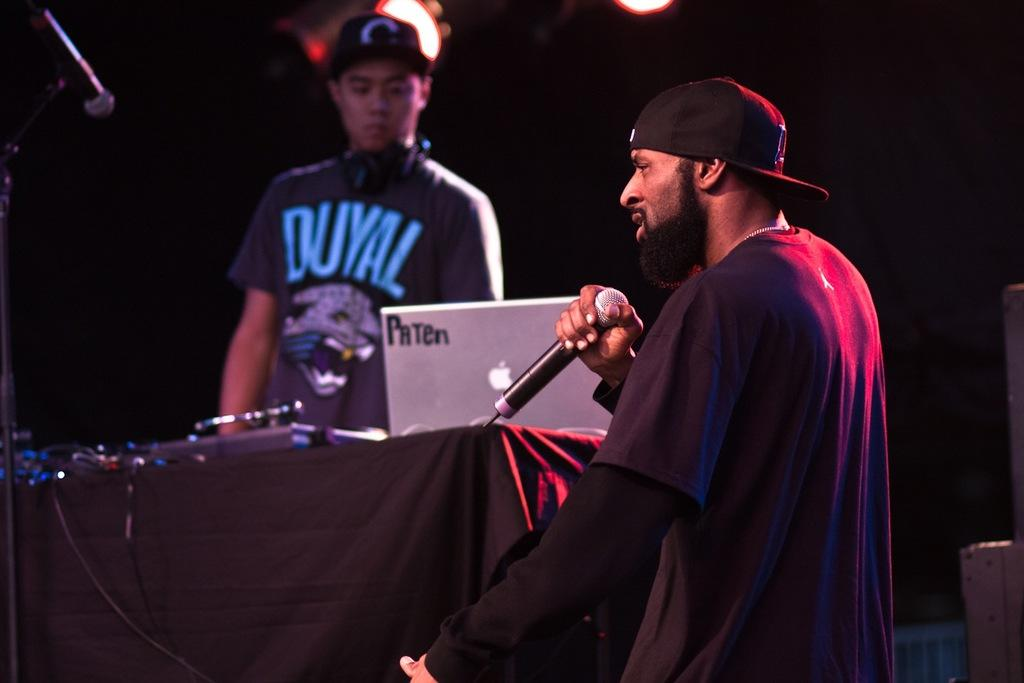How many people are in the image? There are two persons in the image. What is one person doing in the image? One person is talking on a microphone. Can you describe the appearance of the person talking on the microphone? The person is wearing a cap. What is on the table in the image? There is a cloth, a laptop, and a microphone on the table. What is the relationship between the microphone mentioned in point 2 and the one mentioned in point 7? The microphone mentioned in point 7 is the same as the one mentioned in point 2. What can be seen in the image that provides illumination? There are lights visible in the image. What type of coat is the cook wearing in the image? There is no cook present in the image, and therefore no coat can be observed. How does the person's digestion affect the image? There is no information about the person's digestion in the image, so it cannot be determined how it affects the image. 